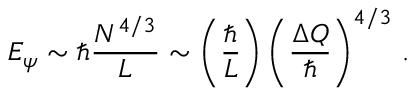<formula> <loc_0><loc_0><loc_500><loc_500>E _ { \psi } \sim \hbar { } N ^ { 4 / 3 } } { L } \sim \left ( \frac { } { L } \right ) \left ( \frac { \Delta Q } { } \right ) ^ { 4 / 3 } \, .</formula> 